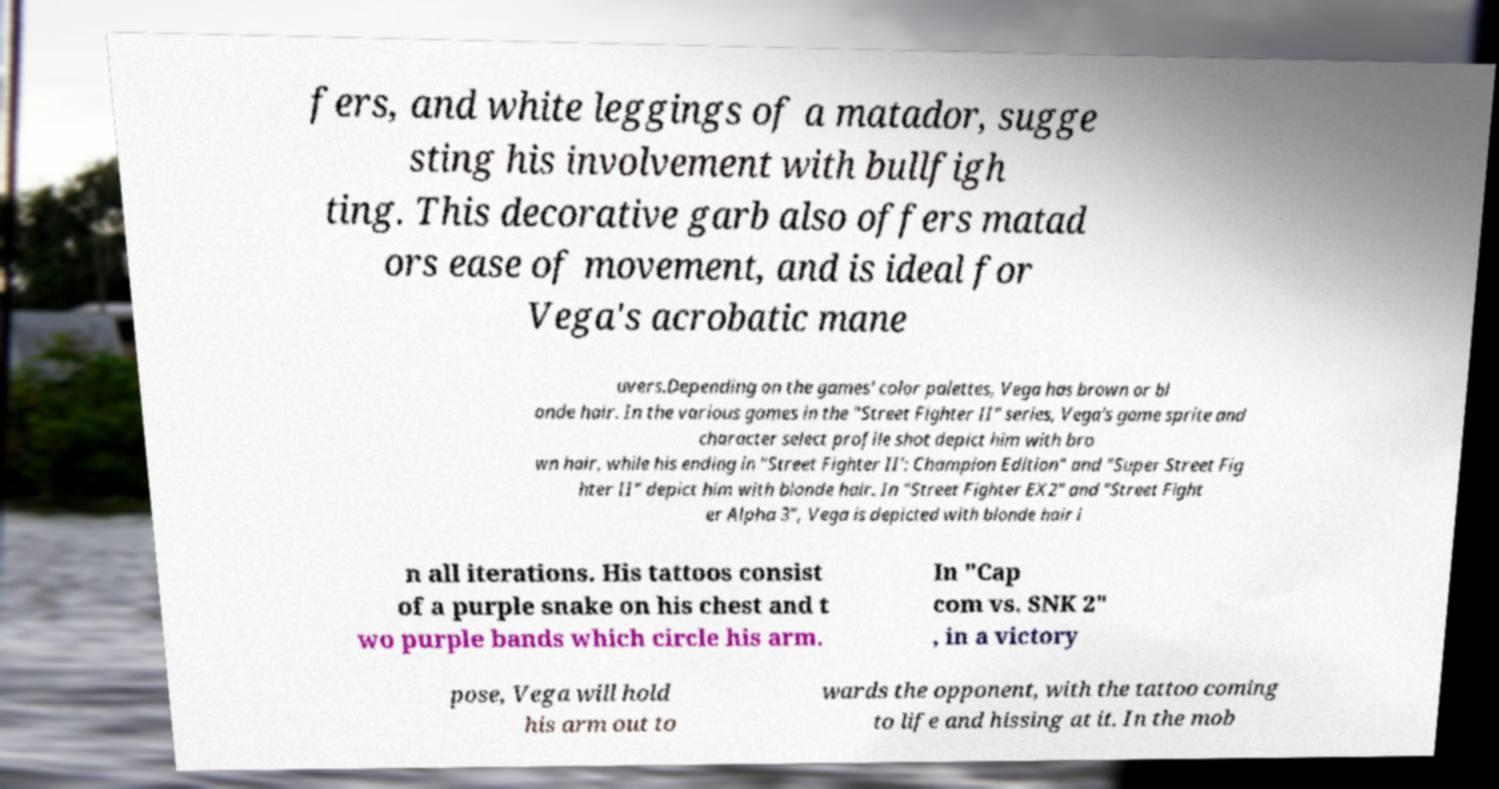Could you extract and type out the text from this image? fers, and white leggings of a matador, sugge sting his involvement with bullfigh ting. This decorative garb also offers matad ors ease of movement, and is ideal for Vega's acrobatic mane uvers.Depending on the games' color palettes, Vega has brown or bl onde hair. In the various games in the "Street Fighter II" series, Vega's game sprite and character select profile shot depict him with bro wn hair, while his ending in "Street Fighter II': Champion Edition" and "Super Street Fig hter II" depict him with blonde hair. In "Street Fighter EX2" and "Street Fight er Alpha 3", Vega is depicted with blonde hair i n all iterations. His tattoos consist of a purple snake on his chest and t wo purple bands which circle his arm. In "Cap com vs. SNK 2" , in a victory pose, Vega will hold his arm out to wards the opponent, with the tattoo coming to life and hissing at it. In the mob 